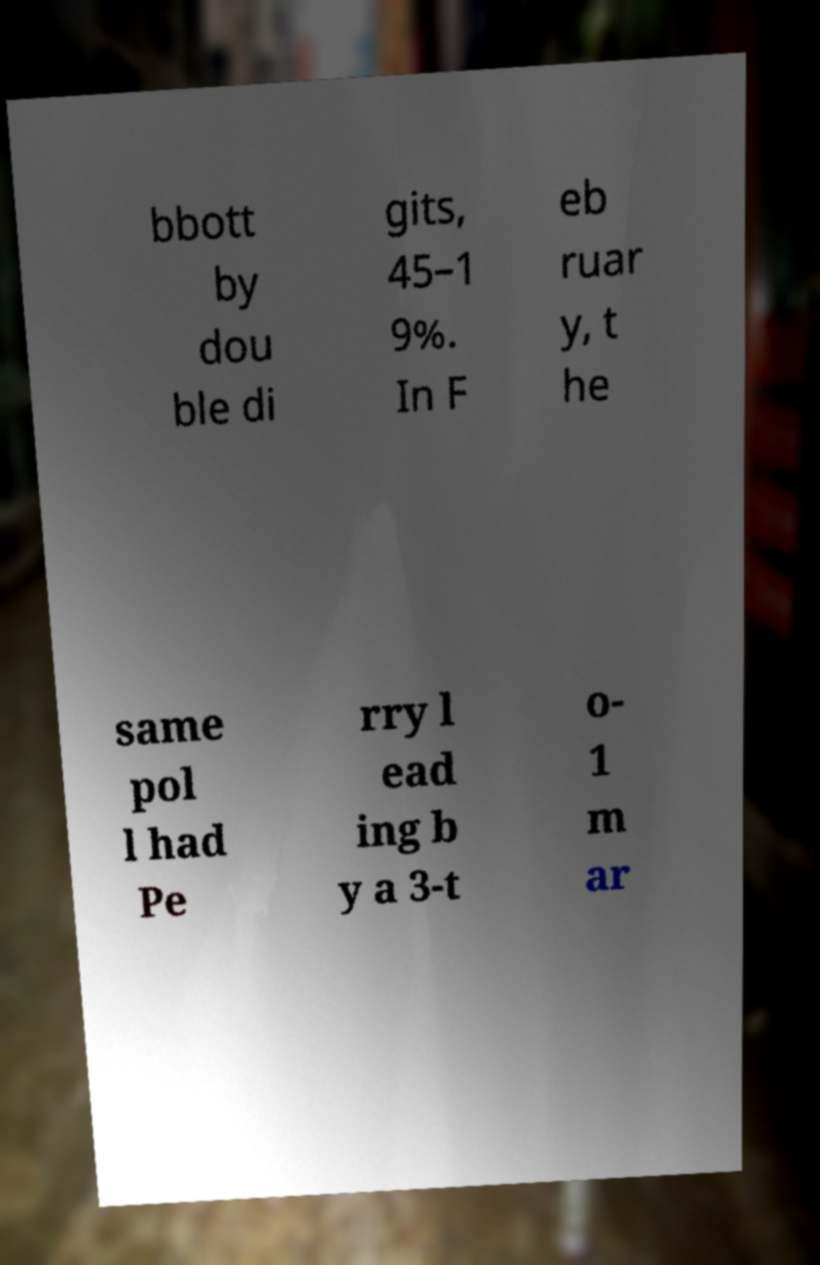There's text embedded in this image that I need extracted. Can you transcribe it verbatim? bbott by dou ble di gits, 45–1 9%. In F eb ruar y, t he same pol l had Pe rry l ead ing b y a 3-t o- 1 m ar 